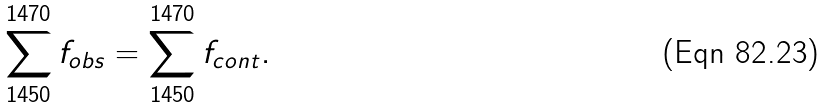Convert formula to latex. <formula><loc_0><loc_0><loc_500><loc_500>\sum _ { 1 4 5 0 } ^ { 1 4 7 0 } f _ { o b s } = \sum _ { 1 4 5 0 } ^ { 1 4 7 0 } f _ { c o n t } .</formula> 